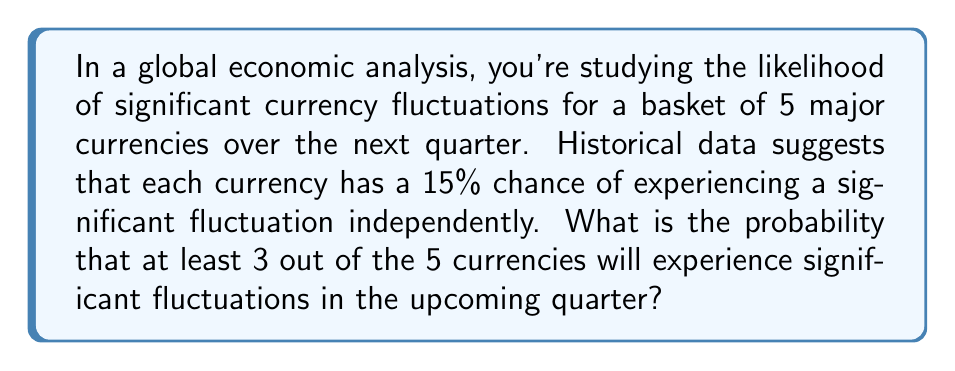Teach me how to tackle this problem. Let's approach this step-by-step using the binomial probability distribution:

1) We have n = 5 currencies, and we're interested in the probability of 3 or more fluctuating.

2) The probability of a single currency fluctuating is p = 0.15.

3) We need to calculate P(X ≥ 3), where X is the number of currencies fluctuating.

4) This is equivalent to 1 - P(X < 3) = 1 - [P(X = 0) + P(X = 1) + P(X = 2)]

5) The binomial probability formula is:

   $$P(X = k) = \binom{n}{k} p^k (1-p)^{n-k}$$

6) Let's calculate each probability:

   P(X = 0) = $\binom{5}{0} (0.15)^0 (0.85)^5 = 1 \cdot 1 \cdot 0.4437 = 0.4437$

   P(X = 1) = $\binom{5}{1} (0.15)^1 (0.85)^4 = 5 \cdot 0.15 \cdot 0.5220 = 0.3915$

   P(X = 2) = $\binom{5}{2} (0.15)^2 (0.85)^3 = 10 \cdot 0.0225 \cdot 0.6141 = 0.1382$

7) Now, we sum these probabilities:

   P(X < 3) = 0.4437 + 0.3915 + 0.1382 = 0.9734

8) Finally, we subtract from 1 to get P(X ≥ 3):

   P(X ≥ 3) = 1 - 0.9734 = 0.0266

Therefore, the probability of at least 3 out of 5 currencies experiencing significant fluctuations is approximately 0.0266 or 2.66%.
Answer: 0.0266 